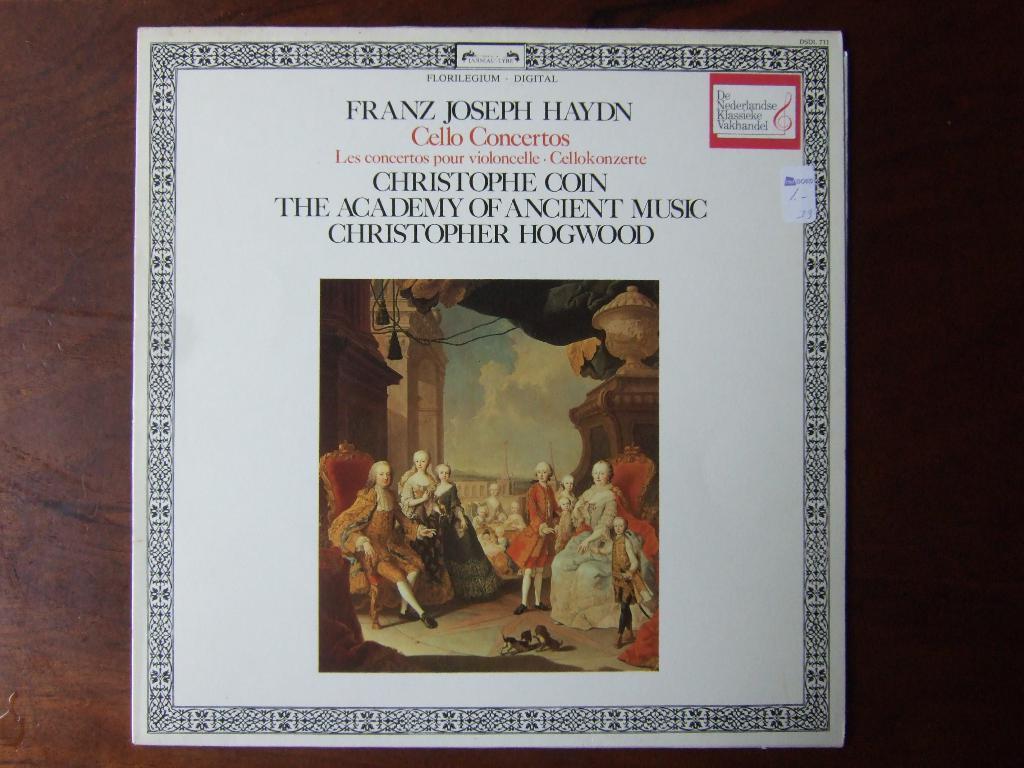What's the name of the academy?
Ensure brevity in your answer.  The academy of ancient music. What instrument is mentioned?
Provide a short and direct response. Cello. 